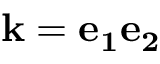<formula> <loc_0><loc_0><loc_500><loc_500>k = e _ { 1 } e _ { 2 }</formula> 